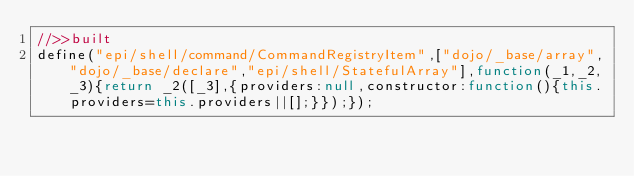<code> <loc_0><loc_0><loc_500><loc_500><_JavaScript_>//>>built
define("epi/shell/command/CommandRegistryItem",["dojo/_base/array","dojo/_base/declare","epi/shell/StatefulArray"],function(_1,_2,_3){return _2([_3],{providers:null,constructor:function(){this.providers=this.providers||[];}});});</code> 